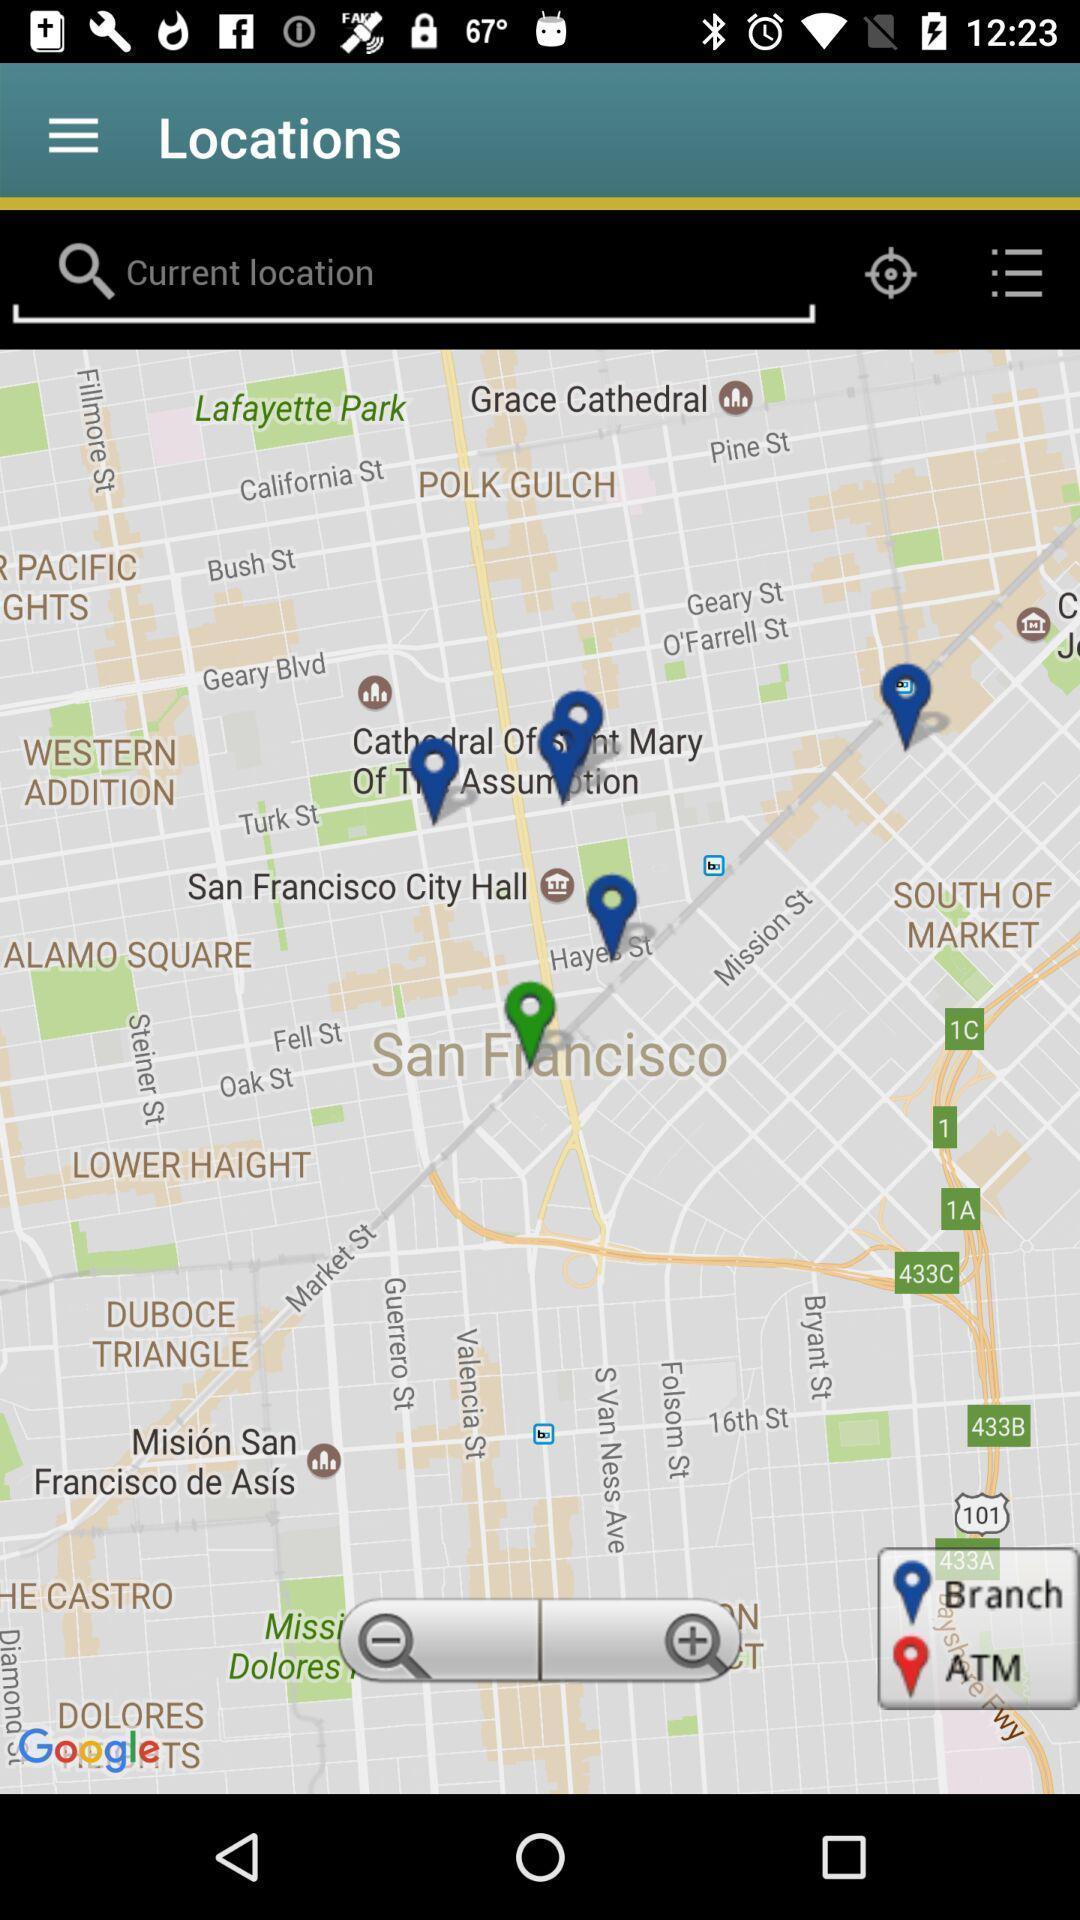Give me a narrative description of this picture. Screen shows search bar to find location. 